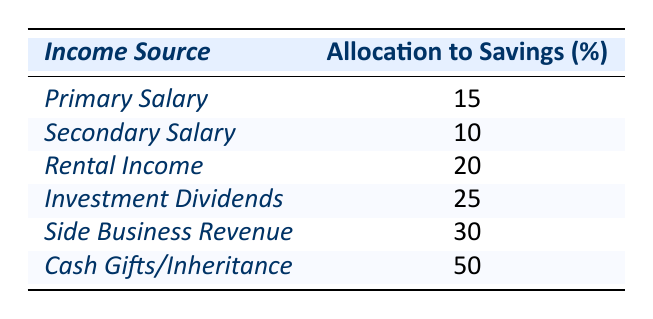What is the highest percentage allocation to savings? The table shows various income sources with their respective percentage allocations to savings. The highest percentage is for "Cash Gifts/Inheritance," which is 50%.
Answer: 50% Which income source has the lowest allocation to savings? Looking at the percentage allocations in the table, the "Secondary Salary" has the lowest allocation at 10%.
Answer: 10% What is the total percentage of savings allocated from "Primary Salary" and "Rental Income"? The table states that "Primary Salary" allocates 15% and "Rental Income" allocates 20% to savings. Adding these gives 15 + 20 = 35%.
Answer: 35% Is the allocation for "Investment Dividends" greater than the allocation for "Side Business Revenue"? Comparing the allocations, "Investment Dividends" is 25% and "Side Business Revenue" is 30%. Since 25% is less than 30%, the statement is false.
Answer: No What is the average allocation to savings from all income sources? To find the average, add all the allocations: 15 + 10 + 20 + 25 + 30 + 50 = 150. There are 6 sources, so the average is 150 / 6 = 25%.
Answer: 25% What is the combined allocation to savings from "Side Business Revenue" and "Investment Dividends"? The "Side Business Revenue" is 30% and "Investment Dividends" is 25%. Adding these gives 30 + 25 = 55%.
Answer: 55% How many income sources allocate more than 20% to savings? Referring to the table, the income sources with allocations more than 20% are "Rental Income" (20%), "Investment Dividends" (25%), "Side Business Revenue" (30%), and "Cash Gifts/Inheritance" (50%). That's four sources.
Answer: 4 Is the total allocation to savings from the "Primary Salary" and "Cash Gifts/Inheritance" equal to 65%? The allocation from "Primary Salary" is 15% and from "Cash Gifts/Inheritance" is 50%. Adding these gives 15 + 50 = 65%, therefore the statement is true.
Answer: Yes If you consider only the top three income sources by allocation, what is their average savings percentage? The top three allocations are 50%, 30%, and 25%. Adding these gives 50 + 30 + 25 = 105%. Dividing by 3 gives an average of 105 / 3 = 35%.
Answer: 35% Which income source contributes a greater percentage to savings: "Rental Income" or "Secondary Salary"? The "Rental Income" has an allocation of 20% and "Secondary Salary" has 10%. Since 20% is greater than 10%, "Rental Income" contributes more.
Answer: Rental Income 